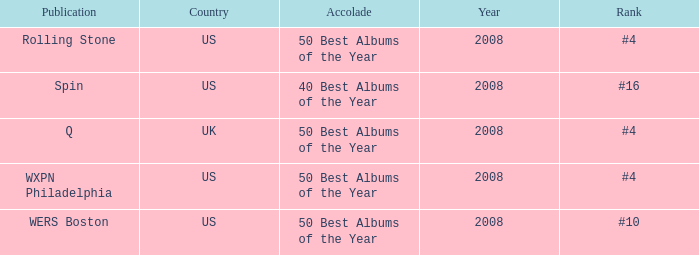Which publication happened in the UK? Q. 